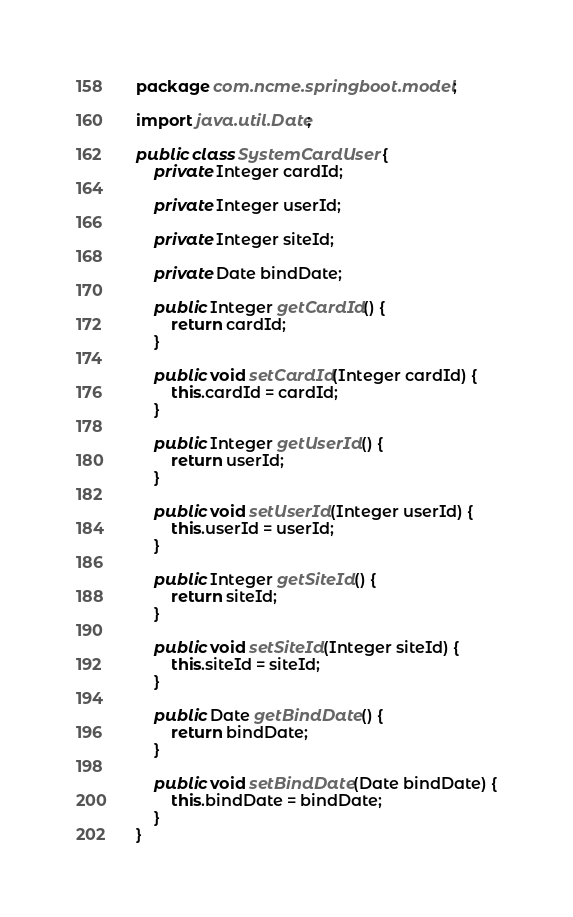Convert code to text. <code><loc_0><loc_0><loc_500><loc_500><_Java_>package com.ncme.springboot.model;

import java.util.Date;

public class SystemCardUser {
    private Integer cardId;

    private Integer userId;

    private Integer siteId;

    private Date bindDate;

    public Integer getCardId() {
        return cardId;
    }

    public void setCardId(Integer cardId) {
        this.cardId = cardId;
    }

    public Integer getUserId() {
        return userId;
    }

    public void setUserId(Integer userId) {
        this.userId = userId;
    }

    public Integer getSiteId() {
        return siteId;
    }

    public void setSiteId(Integer siteId) {
        this.siteId = siteId;
    }

    public Date getBindDate() {
        return bindDate;
    }

    public void setBindDate(Date bindDate) {
        this.bindDate = bindDate;
    }
}</code> 